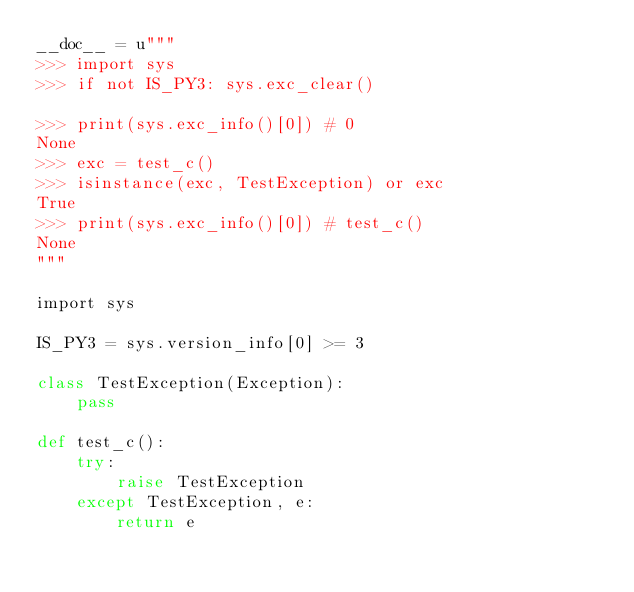Convert code to text. <code><loc_0><loc_0><loc_500><loc_500><_Cython_>__doc__ = u"""
>>> import sys
>>> if not IS_PY3: sys.exc_clear()

>>> print(sys.exc_info()[0]) # 0
None
>>> exc = test_c()
>>> isinstance(exc, TestException) or exc
True
>>> print(sys.exc_info()[0]) # test_c()
None
"""

import sys

IS_PY3 = sys.version_info[0] >= 3

class TestException(Exception):
    pass

def test_c():
    try:
        raise TestException
    except TestException, e:
        return e
</code> 